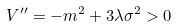Convert formula to latex. <formula><loc_0><loc_0><loc_500><loc_500>V ^ { \prime \prime } = - m ^ { 2 } + 3 \lambda \sigma ^ { 2 } > 0</formula> 